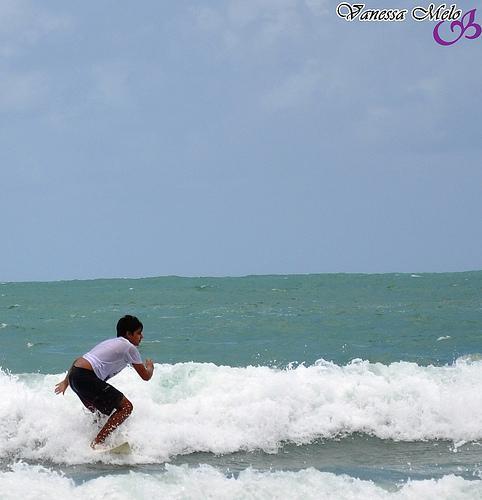How many people are laying in the water?
Give a very brief answer. 0. 